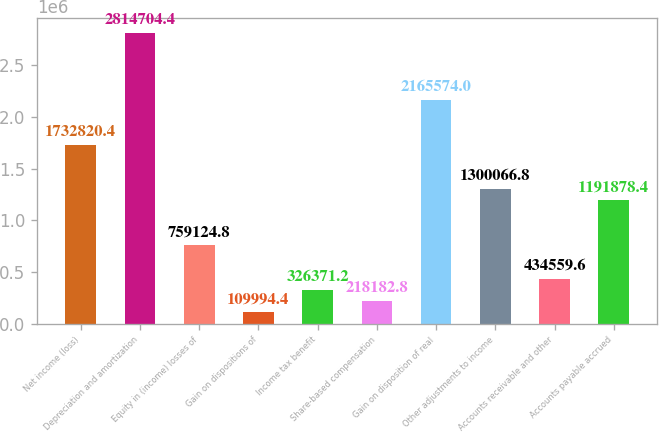Convert chart. <chart><loc_0><loc_0><loc_500><loc_500><bar_chart><fcel>Net income (loss)<fcel>Depreciation and amortization<fcel>Equity in (income) losses of<fcel>Gain on dispositions of<fcel>Income tax benefit<fcel>Share-based compensation<fcel>Gain on disposition of real<fcel>Other adjustments to income<fcel>Accounts receivable and other<fcel>Accounts payable accrued<nl><fcel>1.73282e+06<fcel>2.8147e+06<fcel>759125<fcel>109994<fcel>326371<fcel>218183<fcel>2.16557e+06<fcel>1.30007e+06<fcel>434560<fcel>1.19188e+06<nl></chart> 